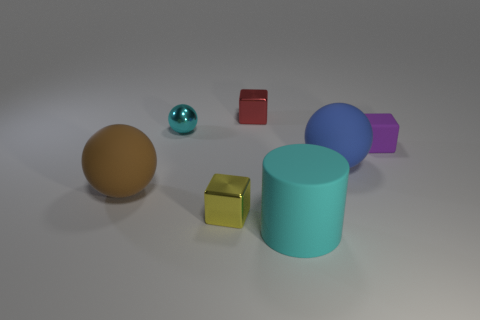Subtract all big rubber balls. How many balls are left? 1 Add 1 small purple cylinders. How many objects exist? 8 Subtract 1 blocks. How many blocks are left? 2 Subtract all brown spheres. How many spheres are left? 2 Subtract all purple balls. How many green cubes are left? 0 Subtract all brown rubber balls. Subtract all metal spheres. How many objects are left? 5 Add 2 tiny purple rubber cubes. How many tiny purple rubber cubes are left? 3 Add 5 tiny green balls. How many tiny green balls exist? 5 Subtract 0 red cylinders. How many objects are left? 7 Subtract all cylinders. How many objects are left? 6 